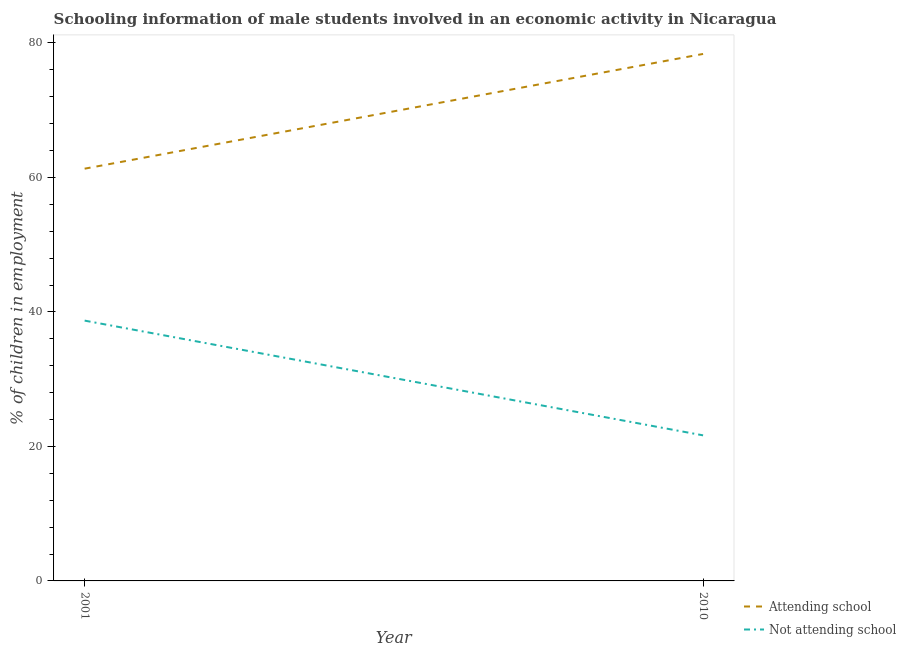How many different coloured lines are there?
Offer a terse response. 2. What is the percentage of employed males who are not attending school in 2010?
Ensure brevity in your answer.  21.64. Across all years, what is the maximum percentage of employed males who are attending school?
Keep it short and to the point. 78.36. Across all years, what is the minimum percentage of employed males who are not attending school?
Make the answer very short. 21.64. In which year was the percentage of employed males who are attending school minimum?
Keep it short and to the point. 2001. What is the total percentage of employed males who are not attending school in the graph?
Ensure brevity in your answer.  60.35. What is the difference between the percentage of employed males who are attending school in 2001 and that in 2010?
Offer a very short reply. -17.06. What is the difference between the percentage of employed males who are attending school in 2001 and the percentage of employed males who are not attending school in 2010?
Make the answer very short. 39.65. What is the average percentage of employed males who are not attending school per year?
Provide a short and direct response. 30.17. In the year 2001, what is the difference between the percentage of employed males who are not attending school and percentage of employed males who are attending school?
Your answer should be very brief. -22.59. In how many years, is the percentage of employed males who are attending school greater than 68 %?
Make the answer very short. 1. What is the ratio of the percentage of employed males who are attending school in 2001 to that in 2010?
Your response must be concise. 0.78. Is the percentage of employed males who are attending school in 2001 less than that in 2010?
Your answer should be very brief. Yes. In how many years, is the percentage of employed males who are not attending school greater than the average percentage of employed males who are not attending school taken over all years?
Provide a succinct answer. 1. Is the percentage of employed males who are not attending school strictly less than the percentage of employed males who are attending school over the years?
Make the answer very short. Yes. How many lines are there?
Ensure brevity in your answer.  2. Does the graph contain any zero values?
Ensure brevity in your answer.  No. How are the legend labels stacked?
Offer a very short reply. Vertical. What is the title of the graph?
Offer a very short reply. Schooling information of male students involved in an economic activity in Nicaragua. Does "% of GNI" appear as one of the legend labels in the graph?
Make the answer very short. No. What is the label or title of the X-axis?
Your response must be concise. Year. What is the label or title of the Y-axis?
Your response must be concise. % of children in employment. What is the % of children in employment of Attending school in 2001?
Offer a terse response. 61.3. What is the % of children in employment of Not attending school in 2001?
Provide a short and direct response. 38.7. What is the % of children in employment in Attending school in 2010?
Your response must be concise. 78.36. What is the % of children in employment of Not attending school in 2010?
Offer a terse response. 21.64. Across all years, what is the maximum % of children in employment of Attending school?
Offer a terse response. 78.36. Across all years, what is the maximum % of children in employment of Not attending school?
Give a very brief answer. 38.7. Across all years, what is the minimum % of children in employment in Attending school?
Your answer should be compact. 61.3. Across all years, what is the minimum % of children in employment in Not attending school?
Your answer should be compact. 21.64. What is the total % of children in employment in Attending school in the graph?
Make the answer very short. 139.65. What is the total % of children in employment in Not attending school in the graph?
Give a very brief answer. 60.35. What is the difference between the % of children in employment of Attending school in 2001 and that in 2010?
Provide a short and direct response. -17.06. What is the difference between the % of children in employment in Not attending school in 2001 and that in 2010?
Your answer should be very brief. 17.06. What is the difference between the % of children in employment in Attending school in 2001 and the % of children in employment in Not attending school in 2010?
Your answer should be very brief. 39.65. What is the average % of children in employment in Attending school per year?
Provide a short and direct response. 69.83. What is the average % of children in employment of Not attending school per year?
Keep it short and to the point. 30.17. In the year 2001, what is the difference between the % of children in employment in Attending school and % of children in employment in Not attending school?
Offer a very short reply. 22.59. In the year 2010, what is the difference between the % of children in employment in Attending school and % of children in employment in Not attending school?
Offer a very short reply. 56.71. What is the ratio of the % of children in employment of Attending school in 2001 to that in 2010?
Make the answer very short. 0.78. What is the ratio of the % of children in employment in Not attending school in 2001 to that in 2010?
Provide a short and direct response. 1.79. What is the difference between the highest and the second highest % of children in employment in Attending school?
Provide a succinct answer. 17.06. What is the difference between the highest and the second highest % of children in employment in Not attending school?
Your answer should be compact. 17.06. What is the difference between the highest and the lowest % of children in employment of Attending school?
Your answer should be compact. 17.06. What is the difference between the highest and the lowest % of children in employment in Not attending school?
Keep it short and to the point. 17.06. 